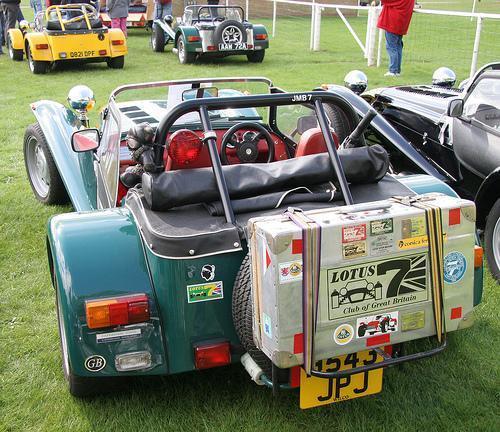How many yellow cars are there?
Give a very brief answer. 1. How many green cars are there?
Give a very brief answer. 2. 